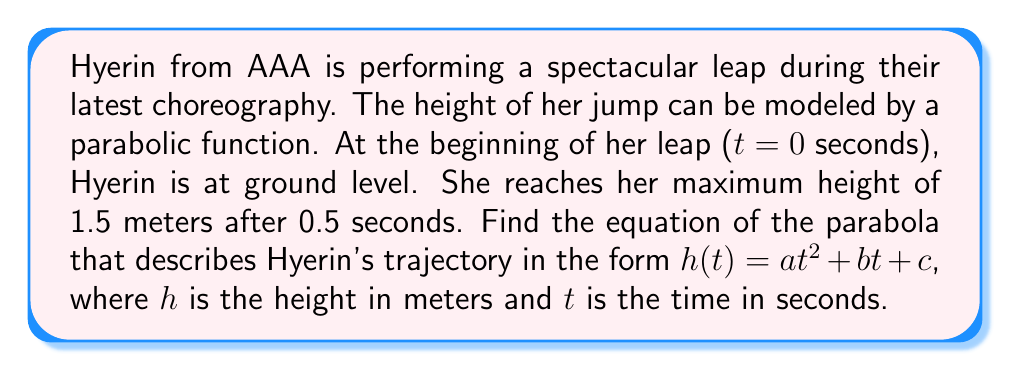Can you solve this math problem? Let's approach this step-by-step:

1) The general form of a parabola is $h(t) = at^2 + bt + c$, where $a$, $b$, and $c$ are constants we need to determine.

2) We know three points on this parabola:
   - At $t = 0$, $h = 0$ (starts at ground level)
   - At $t = 0.5$, $h = 1.5$ (maximum height)
   - The vertex occurs at $t = 0.5$ (since this is when she reaches max height)

3) Let's use the vertex form of a parabola: $h(t) = a(t-p)^2 + q$
   Where $(p,q)$ is the vertex. We know $p = 0.5$ and $q = 1.5$

4) So our equation is: $h(t) = a(t-0.5)^2 + 1.5$

5) Expand this: $h(t) = a(t^2 - t + 0.25) + 1.5$
              $= at^2 - at + 0.25a + 1.5$

6) Now, use the point $(0,0)$ to find $a$:
   $0 = a(0)^2 - a(0) + 0.25a + 1.5$
   $0 = 0.25a + 1.5$
   $-1.5 = 0.25a$
   $a = -6$

7) Now we have all parts of our equation:
   $h(t) = -6t^2 + 6t + 1.5$

This is now in the form $at^2 + bt + c$ where $a = -6$, $b = 6$, and $c = 1.5$.
Answer: $h(t) = -6t^2 + 6t + 1.5$ 